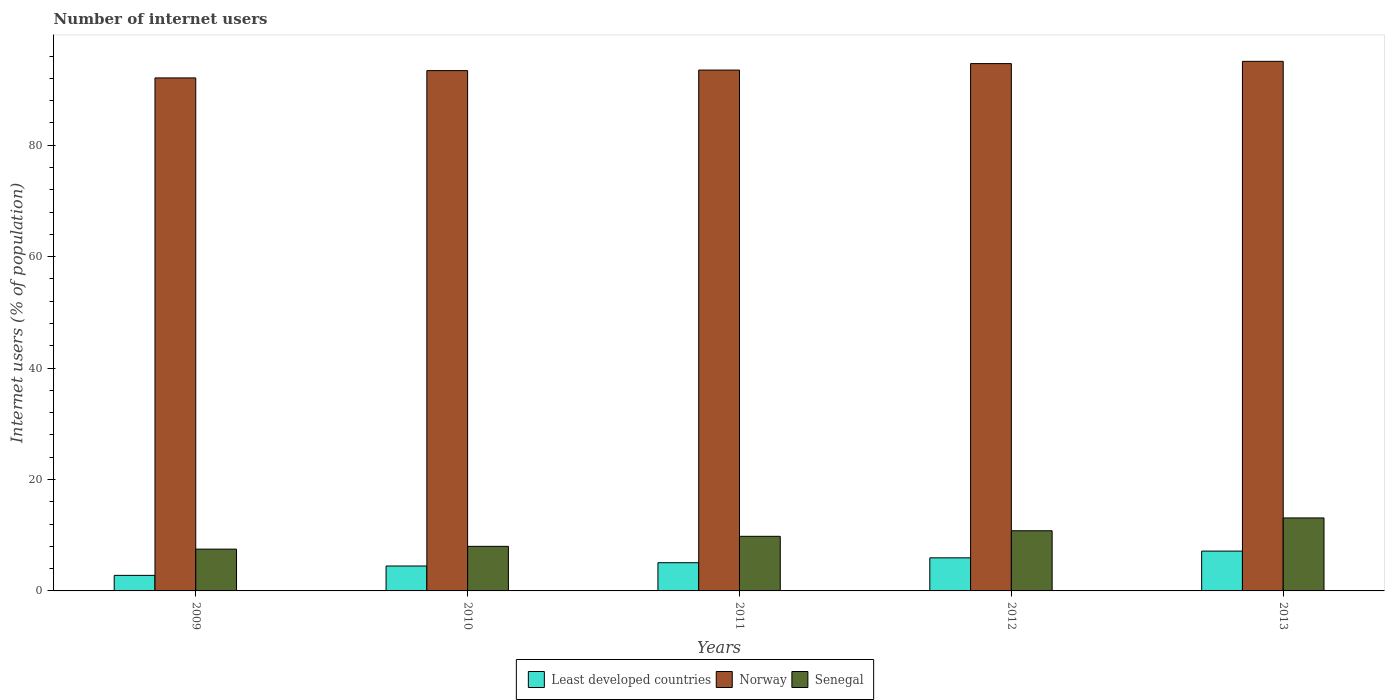How many groups of bars are there?
Provide a short and direct response. 5. Are the number of bars per tick equal to the number of legend labels?
Keep it short and to the point. Yes. Are the number of bars on each tick of the X-axis equal?
Make the answer very short. Yes. What is the label of the 3rd group of bars from the left?
Offer a terse response. 2011. What is the number of internet users in Least developed countries in 2011?
Provide a succinct answer. 5.06. Across all years, what is the maximum number of internet users in Norway?
Your answer should be compact. 95.05. Across all years, what is the minimum number of internet users in Senegal?
Give a very brief answer. 7.5. In which year was the number of internet users in Senegal maximum?
Ensure brevity in your answer.  2013. In which year was the number of internet users in Least developed countries minimum?
Offer a very short reply. 2009. What is the total number of internet users in Norway in the graph?
Provide a short and direct response. 468.66. What is the difference between the number of internet users in Senegal in 2012 and that in 2013?
Your response must be concise. -2.3. What is the difference between the number of internet users in Senegal in 2010 and the number of internet users in Norway in 2009?
Your response must be concise. -84.08. What is the average number of internet users in Least developed countries per year?
Your answer should be very brief. 5.08. In the year 2011, what is the difference between the number of internet users in Senegal and number of internet users in Norway?
Provide a short and direct response. -83.69. What is the ratio of the number of internet users in Norway in 2009 to that in 2013?
Provide a succinct answer. 0.97. Is the number of internet users in Senegal in 2011 less than that in 2013?
Your answer should be very brief. Yes. Is the difference between the number of internet users in Senegal in 2010 and 2011 greater than the difference between the number of internet users in Norway in 2010 and 2011?
Ensure brevity in your answer.  No. What is the difference between the highest and the second highest number of internet users in Norway?
Give a very brief answer. 0.4. What does the 2nd bar from the left in 2010 represents?
Your response must be concise. Norway. What does the 3rd bar from the right in 2010 represents?
Make the answer very short. Least developed countries. Is it the case that in every year, the sum of the number of internet users in Least developed countries and number of internet users in Senegal is greater than the number of internet users in Norway?
Keep it short and to the point. No. Are the values on the major ticks of Y-axis written in scientific E-notation?
Your answer should be very brief. No. Where does the legend appear in the graph?
Offer a very short reply. Bottom center. What is the title of the graph?
Provide a short and direct response. Number of internet users. What is the label or title of the X-axis?
Provide a succinct answer. Years. What is the label or title of the Y-axis?
Provide a short and direct response. Internet users (% of population). What is the Internet users (% of population) of Least developed countries in 2009?
Ensure brevity in your answer.  2.79. What is the Internet users (% of population) of Norway in 2009?
Offer a very short reply. 92.08. What is the Internet users (% of population) in Senegal in 2009?
Make the answer very short. 7.5. What is the Internet users (% of population) of Least developed countries in 2010?
Your response must be concise. 4.47. What is the Internet users (% of population) in Norway in 2010?
Offer a very short reply. 93.39. What is the Internet users (% of population) in Senegal in 2010?
Your response must be concise. 8. What is the Internet users (% of population) in Least developed countries in 2011?
Make the answer very short. 5.06. What is the Internet users (% of population) of Norway in 2011?
Make the answer very short. 93.49. What is the Internet users (% of population) in Least developed countries in 2012?
Provide a short and direct response. 5.94. What is the Internet users (% of population) in Norway in 2012?
Your answer should be compact. 94.65. What is the Internet users (% of population) in Senegal in 2012?
Keep it short and to the point. 10.8. What is the Internet users (% of population) in Least developed countries in 2013?
Give a very brief answer. 7.15. What is the Internet users (% of population) of Norway in 2013?
Your response must be concise. 95.05. What is the Internet users (% of population) in Senegal in 2013?
Your answer should be compact. 13.1. Across all years, what is the maximum Internet users (% of population) of Least developed countries?
Provide a short and direct response. 7.15. Across all years, what is the maximum Internet users (% of population) of Norway?
Make the answer very short. 95.05. Across all years, what is the minimum Internet users (% of population) of Least developed countries?
Your answer should be compact. 2.79. Across all years, what is the minimum Internet users (% of population) of Norway?
Provide a succinct answer. 92.08. What is the total Internet users (% of population) in Least developed countries in the graph?
Provide a short and direct response. 25.41. What is the total Internet users (% of population) in Norway in the graph?
Give a very brief answer. 468.66. What is the total Internet users (% of population) in Senegal in the graph?
Provide a short and direct response. 49.2. What is the difference between the Internet users (% of population) of Least developed countries in 2009 and that in 2010?
Offer a very short reply. -1.68. What is the difference between the Internet users (% of population) in Norway in 2009 and that in 2010?
Your answer should be compact. -1.31. What is the difference between the Internet users (% of population) in Least developed countries in 2009 and that in 2011?
Your response must be concise. -2.27. What is the difference between the Internet users (% of population) of Norway in 2009 and that in 2011?
Offer a very short reply. -1.41. What is the difference between the Internet users (% of population) of Least developed countries in 2009 and that in 2012?
Your answer should be very brief. -3.14. What is the difference between the Internet users (% of population) in Norway in 2009 and that in 2012?
Offer a very short reply. -2.57. What is the difference between the Internet users (% of population) of Least developed countries in 2009 and that in 2013?
Make the answer very short. -4.35. What is the difference between the Internet users (% of population) in Norway in 2009 and that in 2013?
Ensure brevity in your answer.  -2.97. What is the difference between the Internet users (% of population) of Least developed countries in 2010 and that in 2011?
Ensure brevity in your answer.  -0.59. What is the difference between the Internet users (% of population) in Senegal in 2010 and that in 2011?
Your answer should be compact. -1.8. What is the difference between the Internet users (% of population) of Least developed countries in 2010 and that in 2012?
Provide a succinct answer. -1.47. What is the difference between the Internet users (% of population) in Norway in 2010 and that in 2012?
Your answer should be very brief. -1.26. What is the difference between the Internet users (% of population) of Senegal in 2010 and that in 2012?
Your answer should be very brief. -2.8. What is the difference between the Internet users (% of population) in Least developed countries in 2010 and that in 2013?
Offer a very short reply. -2.67. What is the difference between the Internet users (% of population) in Norway in 2010 and that in 2013?
Your answer should be very brief. -1.66. What is the difference between the Internet users (% of population) of Least developed countries in 2011 and that in 2012?
Offer a terse response. -0.87. What is the difference between the Internet users (% of population) in Norway in 2011 and that in 2012?
Keep it short and to the point. -1.16. What is the difference between the Internet users (% of population) in Senegal in 2011 and that in 2012?
Give a very brief answer. -1. What is the difference between the Internet users (% of population) of Least developed countries in 2011 and that in 2013?
Provide a short and direct response. -2.08. What is the difference between the Internet users (% of population) in Norway in 2011 and that in 2013?
Your response must be concise. -1.56. What is the difference between the Internet users (% of population) in Least developed countries in 2012 and that in 2013?
Make the answer very short. -1.21. What is the difference between the Internet users (% of population) of Norway in 2012 and that in 2013?
Your answer should be compact. -0.4. What is the difference between the Internet users (% of population) of Least developed countries in 2009 and the Internet users (% of population) of Norway in 2010?
Give a very brief answer. -90.6. What is the difference between the Internet users (% of population) of Least developed countries in 2009 and the Internet users (% of population) of Senegal in 2010?
Offer a very short reply. -5.21. What is the difference between the Internet users (% of population) of Norway in 2009 and the Internet users (% of population) of Senegal in 2010?
Offer a terse response. 84.08. What is the difference between the Internet users (% of population) in Least developed countries in 2009 and the Internet users (% of population) in Norway in 2011?
Your answer should be compact. -90.7. What is the difference between the Internet users (% of population) of Least developed countries in 2009 and the Internet users (% of population) of Senegal in 2011?
Make the answer very short. -7.01. What is the difference between the Internet users (% of population) of Norway in 2009 and the Internet users (% of population) of Senegal in 2011?
Provide a short and direct response. 82.28. What is the difference between the Internet users (% of population) of Least developed countries in 2009 and the Internet users (% of population) of Norway in 2012?
Provide a succinct answer. -91.86. What is the difference between the Internet users (% of population) in Least developed countries in 2009 and the Internet users (% of population) in Senegal in 2012?
Keep it short and to the point. -8.01. What is the difference between the Internet users (% of population) of Norway in 2009 and the Internet users (% of population) of Senegal in 2012?
Make the answer very short. 81.28. What is the difference between the Internet users (% of population) of Least developed countries in 2009 and the Internet users (% of population) of Norway in 2013?
Provide a succinct answer. -92.26. What is the difference between the Internet users (% of population) of Least developed countries in 2009 and the Internet users (% of population) of Senegal in 2013?
Your answer should be very brief. -10.31. What is the difference between the Internet users (% of population) of Norway in 2009 and the Internet users (% of population) of Senegal in 2013?
Offer a very short reply. 78.98. What is the difference between the Internet users (% of population) of Least developed countries in 2010 and the Internet users (% of population) of Norway in 2011?
Provide a short and direct response. -89.02. What is the difference between the Internet users (% of population) of Least developed countries in 2010 and the Internet users (% of population) of Senegal in 2011?
Offer a very short reply. -5.33. What is the difference between the Internet users (% of population) in Norway in 2010 and the Internet users (% of population) in Senegal in 2011?
Make the answer very short. 83.59. What is the difference between the Internet users (% of population) of Least developed countries in 2010 and the Internet users (% of population) of Norway in 2012?
Make the answer very short. -90.18. What is the difference between the Internet users (% of population) in Least developed countries in 2010 and the Internet users (% of population) in Senegal in 2012?
Keep it short and to the point. -6.33. What is the difference between the Internet users (% of population) of Norway in 2010 and the Internet users (% of population) of Senegal in 2012?
Your response must be concise. 82.59. What is the difference between the Internet users (% of population) in Least developed countries in 2010 and the Internet users (% of population) in Norway in 2013?
Provide a short and direct response. -90.58. What is the difference between the Internet users (% of population) in Least developed countries in 2010 and the Internet users (% of population) in Senegal in 2013?
Your answer should be compact. -8.63. What is the difference between the Internet users (% of population) in Norway in 2010 and the Internet users (% of population) in Senegal in 2013?
Provide a succinct answer. 80.29. What is the difference between the Internet users (% of population) of Least developed countries in 2011 and the Internet users (% of population) of Norway in 2012?
Provide a succinct answer. -89.59. What is the difference between the Internet users (% of population) in Least developed countries in 2011 and the Internet users (% of population) in Senegal in 2012?
Provide a succinct answer. -5.74. What is the difference between the Internet users (% of population) in Norway in 2011 and the Internet users (% of population) in Senegal in 2012?
Offer a terse response. 82.69. What is the difference between the Internet users (% of population) of Least developed countries in 2011 and the Internet users (% of population) of Norway in 2013?
Your response must be concise. -89.99. What is the difference between the Internet users (% of population) in Least developed countries in 2011 and the Internet users (% of population) in Senegal in 2013?
Give a very brief answer. -8.04. What is the difference between the Internet users (% of population) of Norway in 2011 and the Internet users (% of population) of Senegal in 2013?
Provide a succinct answer. 80.39. What is the difference between the Internet users (% of population) in Least developed countries in 2012 and the Internet users (% of population) in Norway in 2013?
Your answer should be very brief. -89.12. What is the difference between the Internet users (% of population) of Least developed countries in 2012 and the Internet users (% of population) of Senegal in 2013?
Ensure brevity in your answer.  -7.16. What is the difference between the Internet users (% of population) of Norway in 2012 and the Internet users (% of population) of Senegal in 2013?
Make the answer very short. 81.55. What is the average Internet users (% of population) of Least developed countries per year?
Give a very brief answer. 5.08. What is the average Internet users (% of population) in Norway per year?
Make the answer very short. 93.73. What is the average Internet users (% of population) of Senegal per year?
Ensure brevity in your answer.  9.84. In the year 2009, what is the difference between the Internet users (% of population) in Least developed countries and Internet users (% of population) in Norway?
Ensure brevity in your answer.  -89.29. In the year 2009, what is the difference between the Internet users (% of population) of Least developed countries and Internet users (% of population) of Senegal?
Offer a terse response. -4.71. In the year 2009, what is the difference between the Internet users (% of population) of Norway and Internet users (% of population) of Senegal?
Your answer should be very brief. 84.58. In the year 2010, what is the difference between the Internet users (% of population) of Least developed countries and Internet users (% of population) of Norway?
Your response must be concise. -88.92. In the year 2010, what is the difference between the Internet users (% of population) of Least developed countries and Internet users (% of population) of Senegal?
Offer a very short reply. -3.53. In the year 2010, what is the difference between the Internet users (% of population) in Norway and Internet users (% of population) in Senegal?
Offer a very short reply. 85.39. In the year 2011, what is the difference between the Internet users (% of population) in Least developed countries and Internet users (% of population) in Norway?
Keep it short and to the point. -88.43. In the year 2011, what is the difference between the Internet users (% of population) in Least developed countries and Internet users (% of population) in Senegal?
Your answer should be very brief. -4.74. In the year 2011, what is the difference between the Internet users (% of population) in Norway and Internet users (% of population) in Senegal?
Your answer should be very brief. 83.69. In the year 2012, what is the difference between the Internet users (% of population) in Least developed countries and Internet users (% of population) in Norway?
Your answer should be compact. -88.71. In the year 2012, what is the difference between the Internet users (% of population) in Least developed countries and Internet users (% of population) in Senegal?
Give a very brief answer. -4.86. In the year 2012, what is the difference between the Internet users (% of population) in Norway and Internet users (% of population) in Senegal?
Provide a succinct answer. 83.85. In the year 2013, what is the difference between the Internet users (% of population) in Least developed countries and Internet users (% of population) in Norway?
Make the answer very short. -87.91. In the year 2013, what is the difference between the Internet users (% of population) in Least developed countries and Internet users (% of population) in Senegal?
Offer a very short reply. -5.95. In the year 2013, what is the difference between the Internet users (% of population) of Norway and Internet users (% of population) of Senegal?
Provide a short and direct response. 81.95. What is the ratio of the Internet users (% of population) in Least developed countries in 2009 to that in 2010?
Provide a short and direct response. 0.62. What is the ratio of the Internet users (% of population) in Norway in 2009 to that in 2010?
Make the answer very short. 0.99. What is the ratio of the Internet users (% of population) of Senegal in 2009 to that in 2010?
Offer a very short reply. 0.94. What is the ratio of the Internet users (% of population) in Least developed countries in 2009 to that in 2011?
Provide a succinct answer. 0.55. What is the ratio of the Internet users (% of population) in Norway in 2009 to that in 2011?
Your answer should be compact. 0.98. What is the ratio of the Internet users (% of population) of Senegal in 2009 to that in 2011?
Ensure brevity in your answer.  0.77. What is the ratio of the Internet users (% of population) in Least developed countries in 2009 to that in 2012?
Provide a short and direct response. 0.47. What is the ratio of the Internet users (% of population) of Norway in 2009 to that in 2012?
Offer a terse response. 0.97. What is the ratio of the Internet users (% of population) of Senegal in 2009 to that in 2012?
Offer a very short reply. 0.69. What is the ratio of the Internet users (% of population) of Least developed countries in 2009 to that in 2013?
Your response must be concise. 0.39. What is the ratio of the Internet users (% of population) in Norway in 2009 to that in 2013?
Give a very brief answer. 0.97. What is the ratio of the Internet users (% of population) of Senegal in 2009 to that in 2013?
Keep it short and to the point. 0.57. What is the ratio of the Internet users (% of population) in Least developed countries in 2010 to that in 2011?
Your answer should be very brief. 0.88. What is the ratio of the Internet users (% of population) of Senegal in 2010 to that in 2011?
Provide a short and direct response. 0.82. What is the ratio of the Internet users (% of population) of Least developed countries in 2010 to that in 2012?
Offer a very short reply. 0.75. What is the ratio of the Internet users (% of population) of Norway in 2010 to that in 2012?
Offer a terse response. 0.99. What is the ratio of the Internet users (% of population) of Senegal in 2010 to that in 2012?
Ensure brevity in your answer.  0.74. What is the ratio of the Internet users (% of population) in Least developed countries in 2010 to that in 2013?
Offer a very short reply. 0.63. What is the ratio of the Internet users (% of population) in Norway in 2010 to that in 2013?
Provide a succinct answer. 0.98. What is the ratio of the Internet users (% of population) of Senegal in 2010 to that in 2013?
Provide a short and direct response. 0.61. What is the ratio of the Internet users (% of population) in Least developed countries in 2011 to that in 2012?
Keep it short and to the point. 0.85. What is the ratio of the Internet users (% of population) of Norway in 2011 to that in 2012?
Make the answer very short. 0.99. What is the ratio of the Internet users (% of population) of Senegal in 2011 to that in 2012?
Keep it short and to the point. 0.91. What is the ratio of the Internet users (% of population) of Least developed countries in 2011 to that in 2013?
Your response must be concise. 0.71. What is the ratio of the Internet users (% of population) in Norway in 2011 to that in 2013?
Provide a succinct answer. 0.98. What is the ratio of the Internet users (% of population) of Senegal in 2011 to that in 2013?
Offer a very short reply. 0.75. What is the ratio of the Internet users (% of population) in Least developed countries in 2012 to that in 2013?
Provide a succinct answer. 0.83. What is the ratio of the Internet users (% of population) in Norway in 2012 to that in 2013?
Keep it short and to the point. 1. What is the ratio of the Internet users (% of population) in Senegal in 2012 to that in 2013?
Your answer should be compact. 0.82. What is the difference between the highest and the second highest Internet users (% of population) of Least developed countries?
Offer a terse response. 1.21. What is the difference between the highest and the second highest Internet users (% of population) of Norway?
Make the answer very short. 0.4. What is the difference between the highest and the lowest Internet users (% of population) of Least developed countries?
Keep it short and to the point. 4.35. What is the difference between the highest and the lowest Internet users (% of population) of Norway?
Ensure brevity in your answer.  2.97. What is the difference between the highest and the lowest Internet users (% of population) of Senegal?
Offer a terse response. 5.6. 